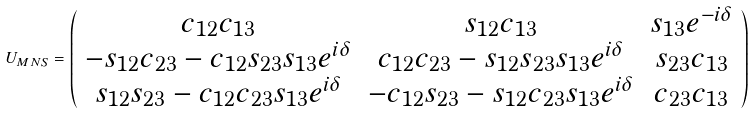Convert formula to latex. <formula><loc_0><loc_0><loc_500><loc_500>U _ { M N S } = \left ( \begin{array} { c c c } c _ { 1 2 } c _ { 1 3 } & s _ { 1 2 } c _ { 1 3 } & s _ { 1 3 } e ^ { - i \delta } \\ - s _ { 1 2 } c _ { 2 3 } - c _ { 1 2 } s _ { 2 3 } s _ { 1 3 } e ^ { i \delta } & c _ { 1 2 } c _ { 2 3 } - s _ { 1 2 } s _ { 2 3 } s _ { 1 3 } e ^ { i \delta } & s _ { 2 3 } c _ { 1 3 } \\ s _ { 1 2 } s _ { 2 3 } - c _ { 1 2 } c _ { 2 3 } s _ { 1 3 } e ^ { i \delta } & - c _ { 1 2 } s _ { 2 3 } - s _ { 1 2 } c _ { 2 3 } s _ { 1 3 } e ^ { i \delta } & c _ { 2 3 } c _ { 1 3 } \\ \end{array} \right )</formula> 